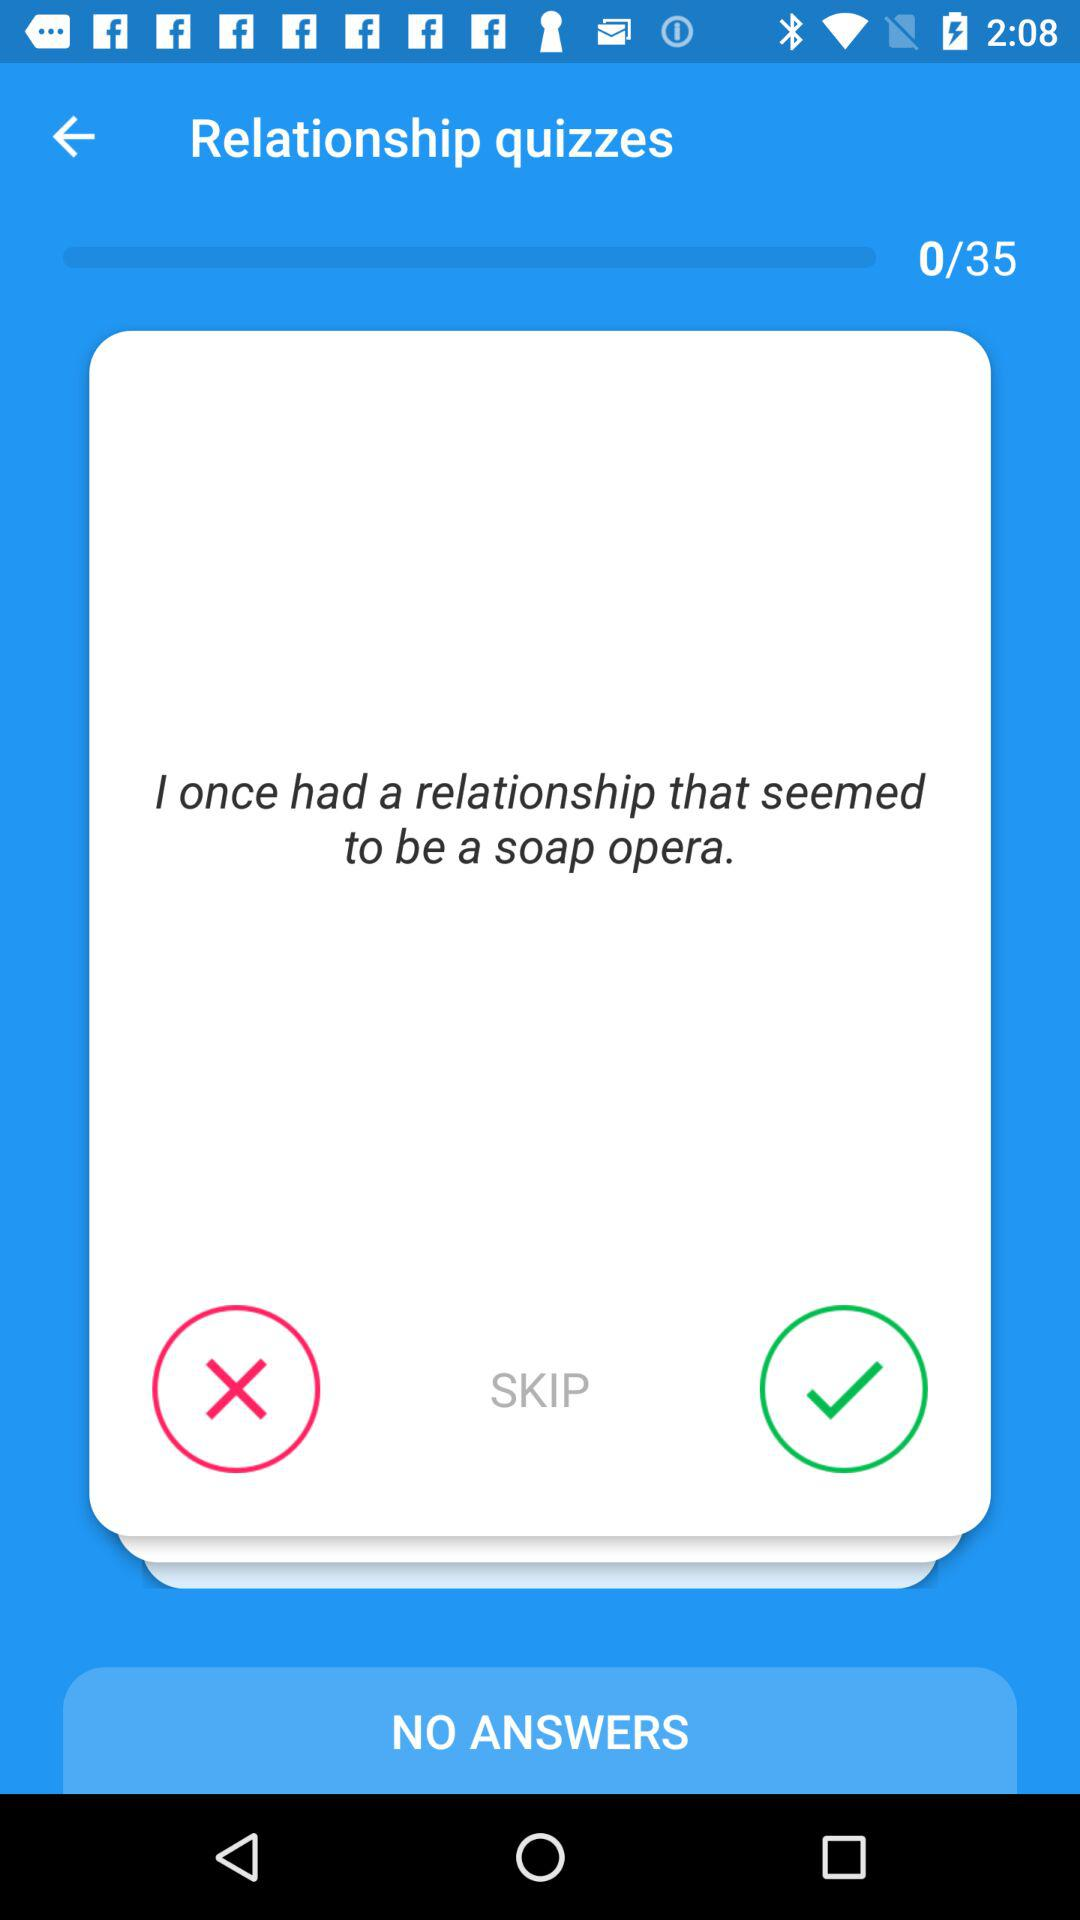What quiz number am I on? You are on quiz number 0. 